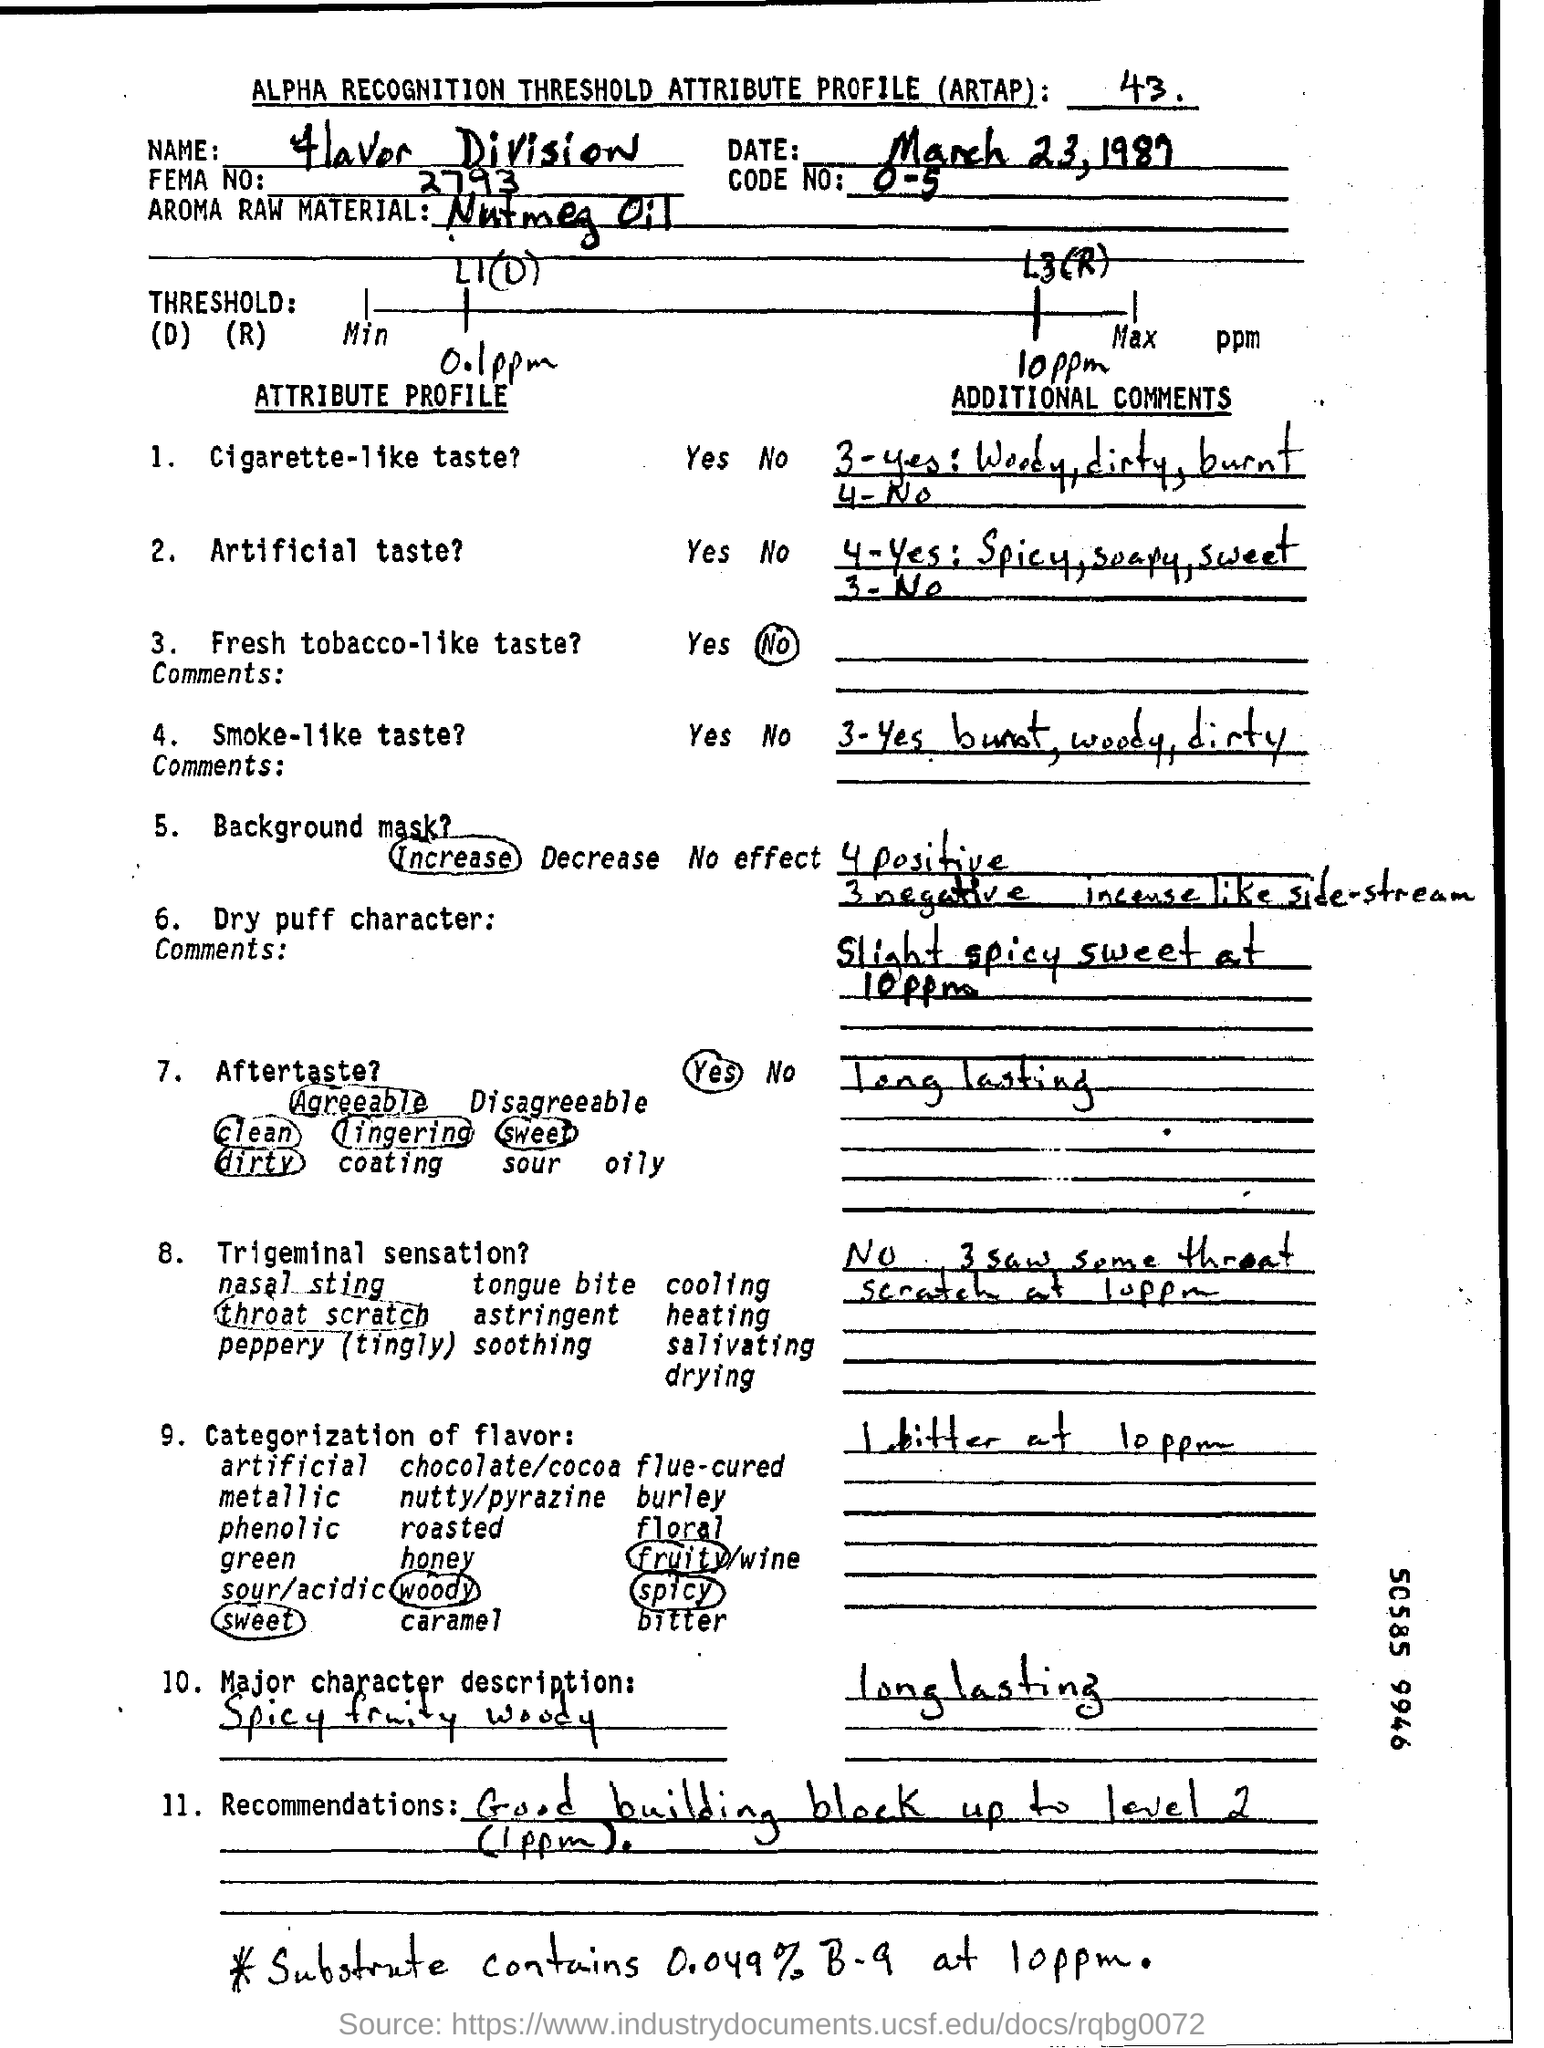What is the date mentioned in the top of the document ?
Give a very brief answer. March 23, 1987. What is the Code Number ?
Keep it short and to the point. 0-5. Which Name written in the Name field ?
Give a very brief answer. Flavor Division. What is written in the Aroma Raw Material Field ?
Give a very brief answer. Nutmeg Oil. What is the FEMA Number ?
Keep it short and to the point. 2793. 